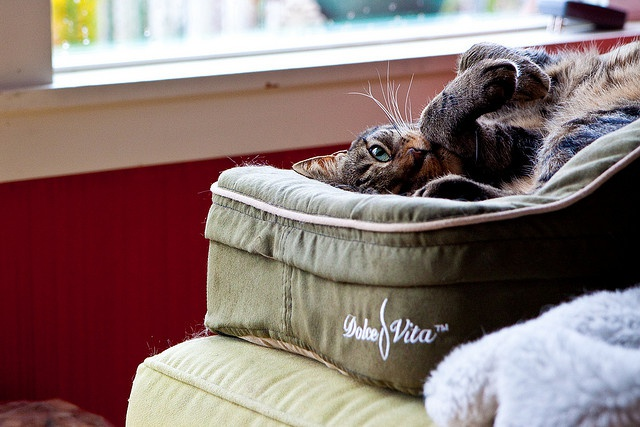Describe the objects in this image and their specific colors. I can see cat in gray, black, darkgray, and lightgray tones and bed in gray, beige, and tan tones in this image. 